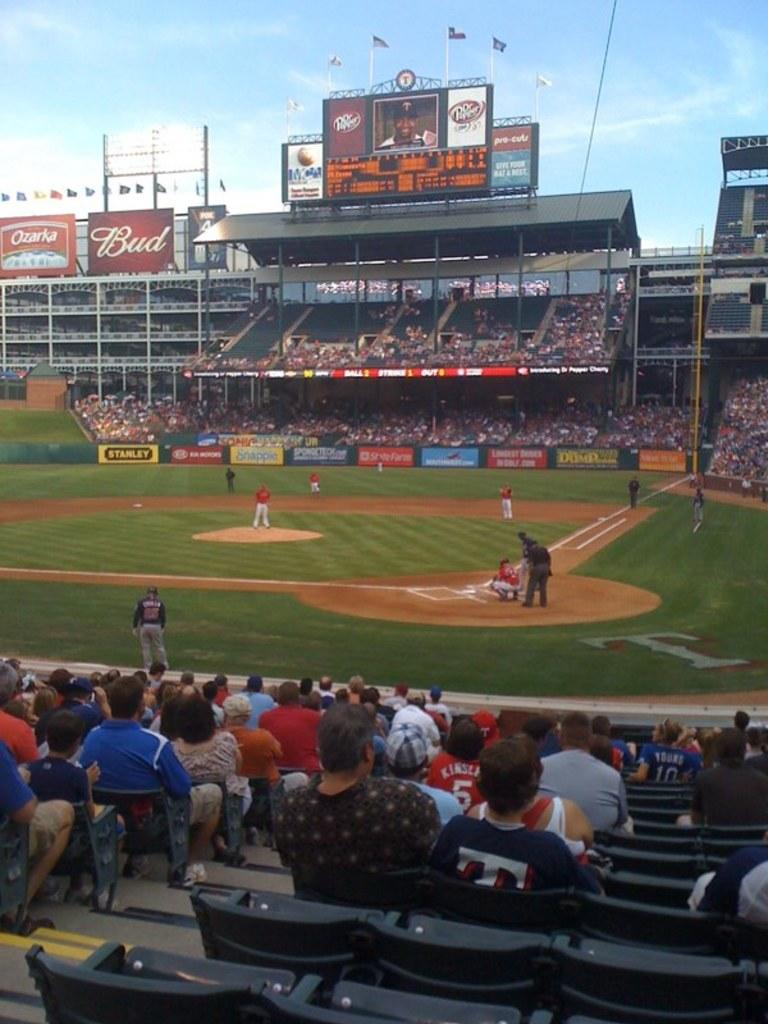<image>
Present a compact description of the photo's key features. A BUD signboard displayed at a baseball game. 